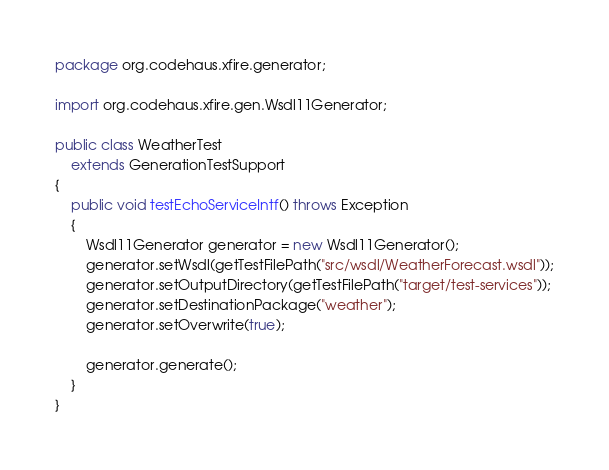Convert code to text. <code><loc_0><loc_0><loc_500><loc_500><_Java_>package org.codehaus.xfire.generator;

import org.codehaus.xfire.gen.Wsdl11Generator;

public class WeatherTest
    extends GenerationTestSupport
{
    public void testEchoServiceIntf() throws Exception
    {
        Wsdl11Generator generator = new Wsdl11Generator();
        generator.setWsdl(getTestFilePath("src/wsdl/WeatherForecast.wsdl"));
        generator.setOutputDirectory(getTestFilePath("target/test-services"));
        generator.setDestinationPackage("weather");
        generator.setOverwrite(true);
        
        generator.generate();        
    }
}
</code> 